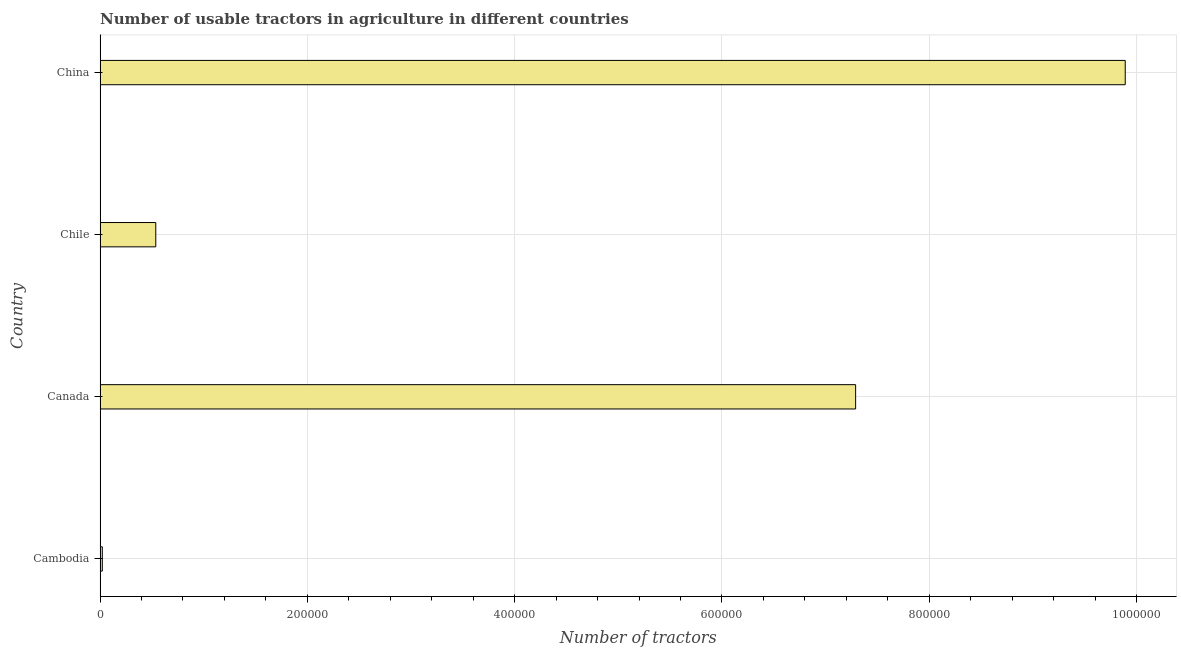Does the graph contain any zero values?
Ensure brevity in your answer.  No. Does the graph contain grids?
Offer a terse response. Yes. What is the title of the graph?
Your response must be concise. Number of usable tractors in agriculture in different countries. What is the label or title of the X-axis?
Provide a succinct answer. Number of tractors. What is the label or title of the Y-axis?
Your answer should be very brief. Country. What is the number of tractors in Canada?
Your answer should be very brief. 7.29e+05. Across all countries, what is the maximum number of tractors?
Ensure brevity in your answer.  9.89e+05. Across all countries, what is the minimum number of tractors?
Provide a short and direct response. 2166. In which country was the number of tractors maximum?
Offer a very short reply. China. In which country was the number of tractors minimum?
Ensure brevity in your answer.  Cambodia. What is the sum of the number of tractors?
Offer a very short reply. 1.77e+06. What is the difference between the number of tractors in Chile and China?
Your answer should be very brief. -9.35e+05. What is the average number of tractors per country?
Give a very brief answer. 4.44e+05. What is the median number of tractors?
Offer a very short reply. 3.91e+05. In how many countries, is the number of tractors greater than 40000 ?
Offer a very short reply. 3. What is the ratio of the number of tractors in Canada to that in China?
Offer a very short reply. 0.74. Is the number of tractors in Cambodia less than that in Canada?
Your answer should be compact. Yes. Is the difference between the number of tractors in Cambodia and Chile greater than the difference between any two countries?
Give a very brief answer. No. What is the difference between the highest and the second highest number of tractors?
Ensure brevity in your answer.  2.60e+05. Is the sum of the number of tractors in Cambodia and China greater than the maximum number of tractors across all countries?
Keep it short and to the point. Yes. What is the difference between the highest and the lowest number of tractors?
Your answer should be very brief. 9.87e+05. Are all the bars in the graph horizontal?
Offer a terse response. Yes. Are the values on the major ticks of X-axis written in scientific E-notation?
Keep it short and to the point. No. What is the Number of tractors of Cambodia?
Your response must be concise. 2166. What is the Number of tractors of Canada?
Keep it short and to the point. 7.29e+05. What is the Number of tractors in Chile?
Your answer should be compact. 5.38e+04. What is the Number of tractors of China?
Keep it short and to the point. 9.89e+05. What is the difference between the Number of tractors in Cambodia and Canada?
Your response must be concise. -7.27e+05. What is the difference between the Number of tractors in Cambodia and Chile?
Offer a terse response. -5.16e+04. What is the difference between the Number of tractors in Cambodia and China?
Make the answer very short. -9.87e+05. What is the difference between the Number of tractors in Canada and Chile?
Your answer should be very brief. 6.75e+05. What is the difference between the Number of tractors in Canada and China?
Offer a terse response. -2.60e+05. What is the difference between the Number of tractors in Chile and China?
Make the answer very short. -9.35e+05. What is the ratio of the Number of tractors in Cambodia to that in Canada?
Keep it short and to the point. 0. What is the ratio of the Number of tractors in Cambodia to that in China?
Provide a succinct answer. 0. What is the ratio of the Number of tractors in Canada to that in Chile?
Your answer should be very brief. 13.56. What is the ratio of the Number of tractors in Canada to that in China?
Give a very brief answer. 0.74. What is the ratio of the Number of tractors in Chile to that in China?
Provide a succinct answer. 0.05. 